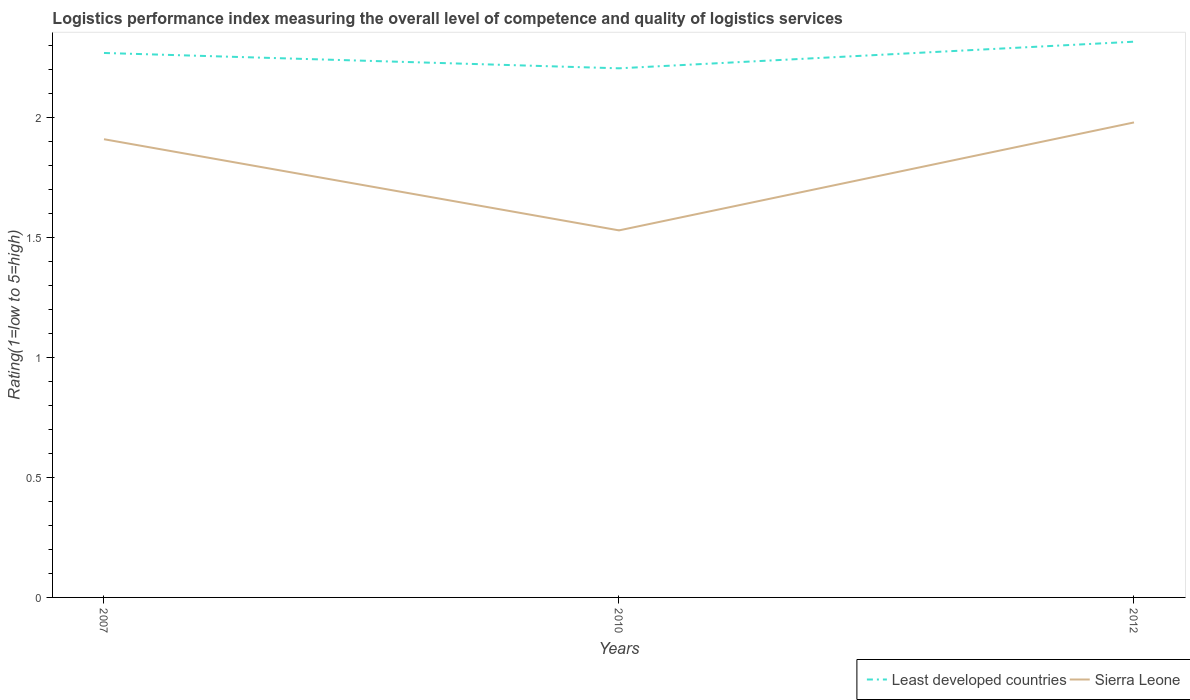How many different coloured lines are there?
Your answer should be very brief. 2. Is the number of lines equal to the number of legend labels?
Give a very brief answer. Yes. Across all years, what is the maximum Logistic performance index in Sierra Leone?
Make the answer very short. 1.53. What is the total Logistic performance index in Sierra Leone in the graph?
Your answer should be very brief. 0.38. What is the difference between the highest and the second highest Logistic performance index in Sierra Leone?
Your response must be concise. 0.45. What is the difference between the highest and the lowest Logistic performance index in Least developed countries?
Provide a short and direct response. 2. Is the Logistic performance index in Least developed countries strictly greater than the Logistic performance index in Sierra Leone over the years?
Your response must be concise. No. How many lines are there?
Your answer should be very brief. 2. How many years are there in the graph?
Keep it short and to the point. 3. Does the graph contain any zero values?
Your response must be concise. No. What is the title of the graph?
Your answer should be compact. Logistics performance index measuring the overall level of competence and quality of logistics services. What is the label or title of the X-axis?
Ensure brevity in your answer.  Years. What is the label or title of the Y-axis?
Your answer should be compact. Rating(1=low to 5=high). What is the Rating(1=low to 5=high) of Least developed countries in 2007?
Keep it short and to the point. 2.27. What is the Rating(1=low to 5=high) in Sierra Leone in 2007?
Ensure brevity in your answer.  1.91. What is the Rating(1=low to 5=high) in Least developed countries in 2010?
Keep it short and to the point. 2.21. What is the Rating(1=low to 5=high) of Sierra Leone in 2010?
Your answer should be compact. 1.53. What is the Rating(1=low to 5=high) of Least developed countries in 2012?
Offer a terse response. 2.32. What is the Rating(1=low to 5=high) in Sierra Leone in 2012?
Your response must be concise. 1.98. Across all years, what is the maximum Rating(1=low to 5=high) in Least developed countries?
Offer a terse response. 2.32. Across all years, what is the maximum Rating(1=low to 5=high) in Sierra Leone?
Offer a very short reply. 1.98. Across all years, what is the minimum Rating(1=low to 5=high) in Least developed countries?
Give a very brief answer. 2.21. Across all years, what is the minimum Rating(1=low to 5=high) of Sierra Leone?
Offer a terse response. 1.53. What is the total Rating(1=low to 5=high) in Least developed countries in the graph?
Offer a very short reply. 6.79. What is the total Rating(1=low to 5=high) in Sierra Leone in the graph?
Offer a terse response. 5.42. What is the difference between the Rating(1=low to 5=high) in Least developed countries in 2007 and that in 2010?
Your answer should be compact. 0.06. What is the difference between the Rating(1=low to 5=high) of Sierra Leone in 2007 and that in 2010?
Your answer should be very brief. 0.38. What is the difference between the Rating(1=low to 5=high) in Least developed countries in 2007 and that in 2012?
Make the answer very short. -0.05. What is the difference between the Rating(1=low to 5=high) in Sierra Leone in 2007 and that in 2012?
Offer a very short reply. -0.07. What is the difference between the Rating(1=low to 5=high) in Least developed countries in 2010 and that in 2012?
Your answer should be very brief. -0.11. What is the difference between the Rating(1=low to 5=high) of Sierra Leone in 2010 and that in 2012?
Ensure brevity in your answer.  -0.45. What is the difference between the Rating(1=low to 5=high) in Least developed countries in 2007 and the Rating(1=low to 5=high) in Sierra Leone in 2010?
Provide a succinct answer. 0.74. What is the difference between the Rating(1=low to 5=high) of Least developed countries in 2007 and the Rating(1=low to 5=high) of Sierra Leone in 2012?
Your response must be concise. 0.29. What is the difference between the Rating(1=low to 5=high) in Least developed countries in 2010 and the Rating(1=low to 5=high) in Sierra Leone in 2012?
Offer a terse response. 0.23. What is the average Rating(1=low to 5=high) in Least developed countries per year?
Provide a short and direct response. 2.26. What is the average Rating(1=low to 5=high) in Sierra Leone per year?
Your response must be concise. 1.81. In the year 2007, what is the difference between the Rating(1=low to 5=high) of Least developed countries and Rating(1=low to 5=high) of Sierra Leone?
Make the answer very short. 0.36. In the year 2010, what is the difference between the Rating(1=low to 5=high) of Least developed countries and Rating(1=low to 5=high) of Sierra Leone?
Keep it short and to the point. 0.68. In the year 2012, what is the difference between the Rating(1=low to 5=high) in Least developed countries and Rating(1=low to 5=high) in Sierra Leone?
Provide a succinct answer. 0.34. What is the ratio of the Rating(1=low to 5=high) of Sierra Leone in 2007 to that in 2010?
Ensure brevity in your answer.  1.25. What is the ratio of the Rating(1=low to 5=high) in Least developed countries in 2007 to that in 2012?
Keep it short and to the point. 0.98. What is the ratio of the Rating(1=low to 5=high) in Sierra Leone in 2007 to that in 2012?
Provide a succinct answer. 0.96. What is the ratio of the Rating(1=low to 5=high) in Least developed countries in 2010 to that in 2012?
Your response must be concise. 0.95. What is the ratio of the Rating(1=low to 5=high) in Sierra Leone in 2010 to that in 2012?
Your response must be concise. 0.77. What is the difference between the highest and the second highest Rating(1=low to 5=high) of Least developed countries?
Provide a short and direct response. 0.05. What is the difference between the highest and the second highest Rating(1=low to 5=high) of Sierra Leone?
Provide a short and direct response. 0.07. What is the difference between the highest and the lowest Rating(1=low to 5=high) of Least developed countries?
Provide a short and direct response. 0.11. What is the difference between the highest and the lowest Rating(1=low to 5=high) in Sierra Leone?
Your response must be concise. 0.45. 